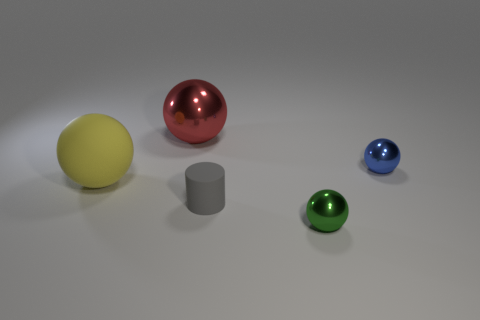Can you tell me the different sizes of balls in the image? Certainly! The image features balls of varying sizes; there’s a large yellow ball, a medium-sized red ball, and smaller blue and green balls. Which one is the largest? The yellow ball is the largest among the ones visible in the image. 